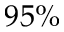<formula> <loc_0><loc_0><loc_500><loc_500>9 5 \%</formula> 